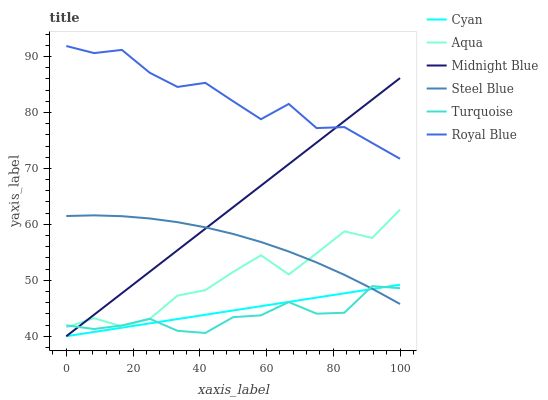Does Midnight Blue have the minimum area under the curve?
Answer yes or no. No. Does Midnight Blue have the maximum area under the curve?
Answer yes or no. No. Is Aqua the smoothest?
Answer yes or no. No. Is Midnight Blue the roughest?
Answer yes or no. No. Does Aqua have the lowest value?
Answer yes or no. No. Does Midnight Blue have the highest value?
Answer yes or no. No. Is Turquoise less than Royal Blue?
Answer yes or no. Yes. Is Aqua greater than Cyan?
Answer yes or no. Yes. Does Turquoise intersect Royal Blue?
Answer yes or no. No. 